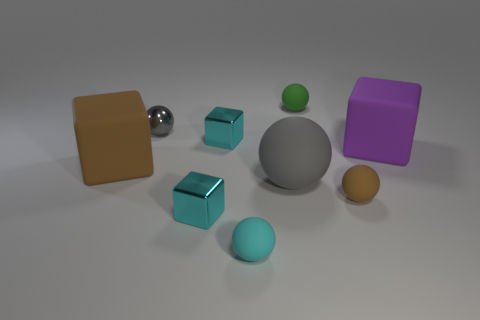What size is the other ball that is the same color as the metal sphere?
Offer a very short reply. Large. Is there a large object that has the same color as the metallic sphere?
Ensure brevity in your answer.  Yes. Does the small brown thing have the same material as the small gray ball?
Keep it short and to the point. No. Does the big rubber ball have the same color as the small shiny ball that is right of the brown block?
Your answer should be very brief. Yes. There is a large thing that is left of the cyan ball; what material is it?
Offer a terse response. Rubber. Does the green sphere have the same size as the brown matte ball?
Keep it short and to the point. Yes. How many other things are the same size as the purple object?
Give a very brief answer. 2. Is the color of the big matte ball the same as the shiny ball?
Ensure brevity in your answer.  Yes. What shape is the brown thing that is behind the large thing in front of the large cube to the left of the big rubber ball?
Your response must be concise. Cube. How many objects are either metallic things in front of the purple rubber object or large purple blocks that are behind the brown matte sphere?
Keep it short and to the point. 2. 